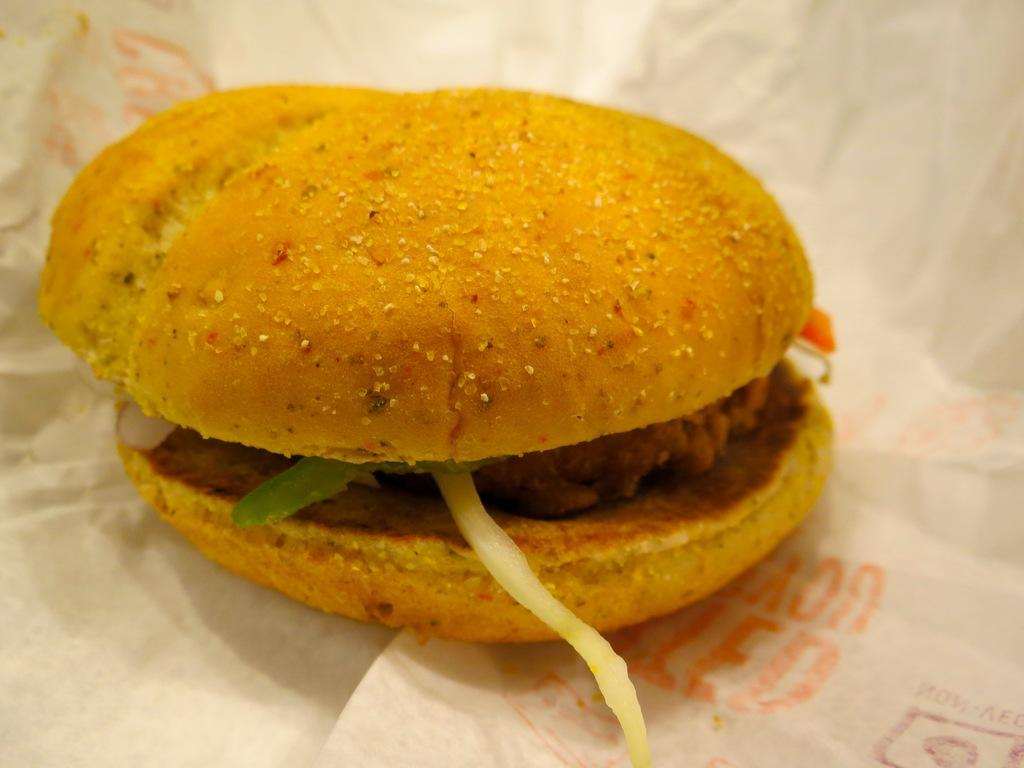What is the main subject of the image? There is a burger in the image. Where is the burger located in the image? The burger is in the middle of the image. What is the burger placed on? The burger is placed on a white-colored paper. How many eggs are visible in the image? There are no eggs present in the image; it features a burger placed on a white-colored paper. What type of brain is shown in the image? There is no brain present in the image; it features a burger placed on a white-colored paper. 